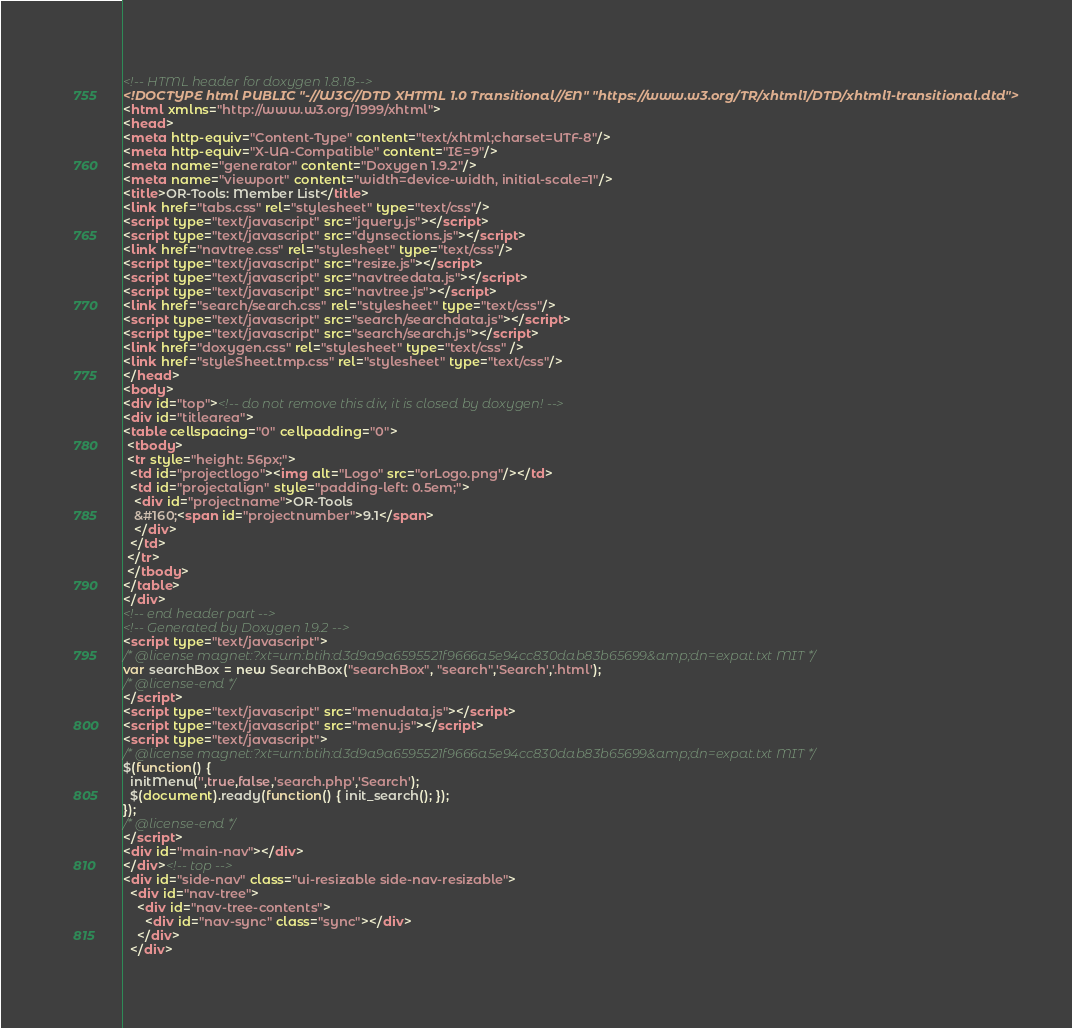Convert code to text. <code><loc_0><loc_0><loc_500><loc_500><_HTML_><!-- HTML header for doxygen 1.8.18-->
<!DOCTYPE html PUBLIC "-//W3C//DTD XHTML 1.0 Transitional//EN" "https://www.w3.org/TR/xhtml1/DTD/xhtml1-transitional.dtd">
<html xmlns="http://www.w3.org/1999/xhtml">
<head>
<meta http-equiv="Content-Type" content="text/xhtml;charset=UTF-8"/>
<meta http-equiv="X-UA-Compatible" content="IE=9"/>
<meta name="generator" content="Doxygen 1.9.2"/>
<meta name="viewport" content="width=device-width, initial-scale=1"/>
<title>OR-Tools: Member List</title>
<link href="tabs.css" rel="stylesheet" type="text/css"/>
<script type="text/javascript" src="jquery.js"></script>
<script type="text/javascript" src="dynsections.js"></script>
<link href="navtree.css" rel="stylesheet" type="text/css"/>
<script type="text/javascript" src="resize.js"></script>
<script type="text/javascript" src="navtreedata.js"></script>
<script type="text/javascript" src="navtree.js"></script>
<link href="search/search.css" rel="stylesheet" type="text/css"/>
<script type="text/javascript" src="search/searchdata.js"></script>
<script type="text/javascript" src="search/search.js"></script>
<link href="doxygen.css" rel="stylesheet" type="text/css" />
<link href="styleSheet.tmp.css" rel="stylesheet" type="text/css"/>
</head>
<body>
<div id="top"><!-- do not remove this div, it is closed by doxygen! -->
<div id="titlearea">
<table cellspacing="0" cellpadding="0">
 <tbody>
 <tr style="height: 56px;">
  <td id="projectlogo"><img alt="Logo" src="orLogo.png"/></td>
  <td id="projectalign" style="padding-left: 0.5em;">
   <div id="projectname">OR-Tools
   &#160;<span id="projectnumber">9.1</span>
   </div>
  </td>
 </tr>
 </tbody>
</table>
</div>
<!-- end header part -->
<!-- Generated by Doxygen 1.9.2 -->
<script type="text/javascript">
/* @license magnet:?xt=urn:btih:d3d9a9a6595521f9666a5e94cc830dab83b65699&amp;dn=expat.txt MIT */
var searchBox = new SearchBox("searchBox", "search",'Search','.html');
/* @license-end */
</script>
<script type="text/javascript" src="menudata.js"></script>
<script type="text/javascript" src="menu.js"></script>
<script type="text/javascript">
/* @license magnet:?xt=urn:btih:d3d9a9a6595521f9666a5e94cc830dab83b65699&amp;dn=expat.txt MIT */
$(function() {
  initMenu('',true,false,'search.php','Search');
  $(document).ready(function() { init_search(); });
});
/* @license-end */
</script>
<div id="main-nav"></div>
</div><!-- top -->
<div id="side-nav" class="ui-resizable side-nav-resizable">
  <div id="nav-tree">
    <div id="nav-tree-contents">
      <div id="nav-sync" class="sync"></div>
    </div>
  </div></code> 